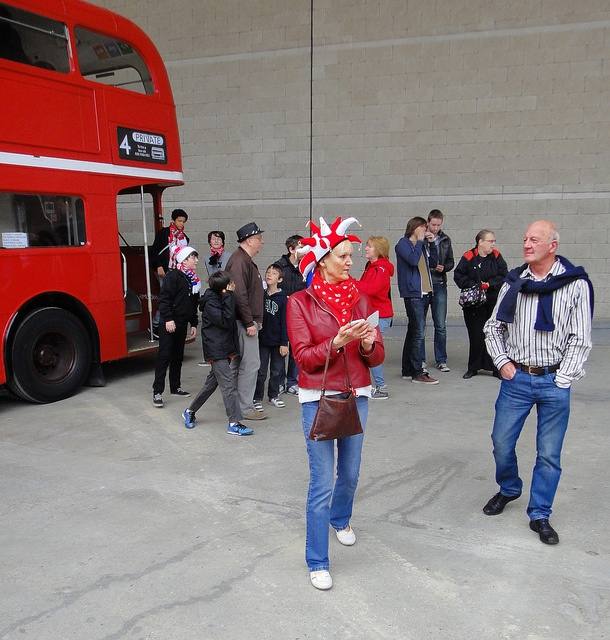Describe the objects in this image and their specific colors. I can see bus in maroon, brown, black, and gray tones, people in maroon, navy, lightgray, darkgray, and black tones, people in maroon, brown, and gray tones, people in maroon, black, navy, gray, and darkgray tones, and people in maroon, black, gray, and darkgray tones in this image. 